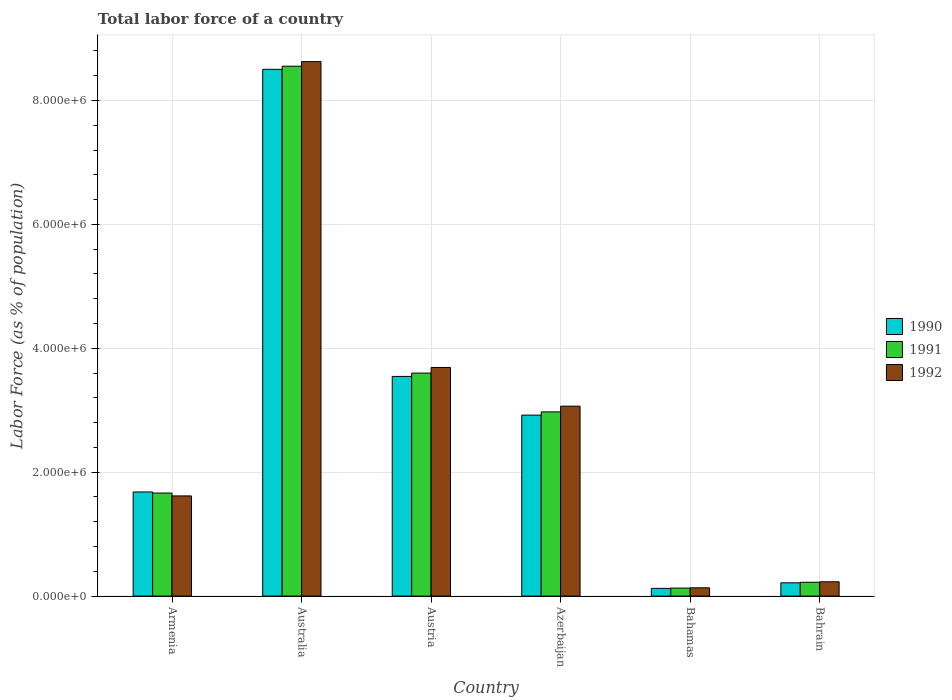How many different coloured bars are there?
Keep it short and to the point. 3. Are the number of bars per tick equal to the number of legend labels?
Your response must be concise. Yes. How many bars are there on the 1st tick from the left?
Your answer should be very brief. 3. How many bars are there on the 3rd tick from the right?
Your response must be concise. 3. What is the label of the 3rd group of bars from the left?
Offer a very short reply. Austria. In how many cases, is the number of bars for a given country not equal to the number of legend labels?
Provide a succinct answer. 0. What is the percentage of labor force in 1992 in Armenia?
Give a very brief answer. 1.62e+06. Across all countries, what is the maximum percentage of labor force in 1992?
Offer a very short reply. 8.63e+06. Across all countries, what is the minimum percentage of labor force in 1991?
Make the answer very short. 1.30e+05. In which country was the percentage of labor force in 1991 minimum?
Ensure brevity in your answer.  Bahamas. What is the total percentage of labor force in 1991 in the graph?
Give a very brief answer. 1.71e+07. What is the difference between the percentage of labor force in 1991 in Armenia and that in Australia?
Your answer should be very brief. -6.89e+06. What is the difference between the percentage of labor force in 1990 in Azerbaijan and the percentage of labor force in 1991 in Bahamas?
Offer a very short reply. 2.79e+06. What is the average percentage of labor force in 1990 per country?
Ensure brevity in your answer.  2.83e+06. What is the difference between the percentage of labor force of/in 1990 and percentage of labor force of/in 1991 in Australia?
Your response must be concise. -5.07e+04. In how many countries, is the percentage of labor force in 1991 greater than 2800000 %?
Offer a very short reply. 3. What is the ratio of the percentage of labor force in 1991 in Australia to that in Austria?
Ensure brevity in your answer.  2.38. Is the percentage of labor force in 1991 in Australia less than that in Austria?
Your answer should be very brief. No. Is the difference between the percentage of labor force in 1990 in Austria and Bahrain greater than the difference between the percentage of labor force in 1991 in Austria and Bahrain?
Keep it short and to the point. No. What is the difference between the highest and the second highest percentage of labor force in 1990?
Your answer should be very brief. 4.96e+06. What is the difference between the highest and the lowest percentage of labor force in 1991?
Your answer should be very brief. 8.42e+06. Is the sum of the percentage of labor force in 1990 in Australia and Azerbaijan greater than the maximum percentage of labor force in 1992 across all countries?
Provide a succinct answer. Yes. Is it the case that in every country, the sum of the percentage of labor force in 1992 and percentage of labor force in 1991 is greater than the percentage of labor force in 1990?
Offer a terse response. Yes. Are all the bars in the graph horizontal?
Offer a very short reply. No. How many countries are there in the graph?
Make the answer very short. 6. What is the difference between two consecutive major ticks on the Y-axis?
Your answer should be very brief. 2.00e+06. Are the values on the major ticks of Y-axis written in scientific E-notation?
Make the answer very short. Yes. Where does the legend appear in the graph?
Provide a short and direct response. Center right. How many legend labels are there?
Your response must be concise. 3. What is the title of the graph?
Your answer should be very brief. Total labor force of a country. Does "1978" appear as one of the legend labels in the graph?
Ensure brevity in your answer.  No. What is the label or title of the X-axis?
Make the answer very short. Country. What is the label or title of the Y-axis?
Provide a short and direct response. Labor Force (as % of population). What is the Labor Force (as % of population) of 1990 in Armenia?
Keep it short and to the point. 1.68e+06. What is the Labor Force (as % of population) of 1991 in Armenia?
Ensure brevity in your answer.  1.66e+06. What is the Labor Force (as % of population) of 1992 in Armenia?
Keep it short and to the point. 1.62e+06. What is the Labor Force (as % of population) in 1990 in Australia?
Your answer should be very brief. 8.50e+06. What is the Labor Force (as % of population) in 1991 in Australia?
Keep it short and to the point. 8.55e+06. What is the Labor Force (as % of population) in 1992 in Australia?
Your response must be concise. 8.63e+06. What is the Labor Force (as % of population) in 1990 in Austria?
Offer a terse response. 3.55e+06. What is the Labor Force (as % of population) of 1991 in Austria?
Offer a very short reply. 3.60e+06. What is the Labor Force (as % of population) in 1992 in Austria?
Provide a short and direct response. 3.69e+06. What is the Labor Force (as % of population) in 1990 in Azerbaijan?
Make the answer very short. 2.92e+06. What is the Labor Force (as % of population) of 1991 in Azerbaijan?
Your answer should be very brief. 2.97e+06. What is the Labor Force (as % of population) of 1992 in Azerbaijan?
Make the answer very short. 3.07e+06. What is the Labor Force (as % of population) in 1990 in Bahamas?
Keep it short and to the point. 1.25e+05. What is the Labor Force (as % of population) in 1991 in Bahamas?
Your answer should be compact. 1.30e+05. What is the Labor Force (as % of population) in 1992 in Bahamas?
Your response must be concise. 1.34e+05. What is the Labor Force (as % of population) of 1990 in Bahrain?
Your answer should be compact. 2.15e+05. What is the Labor Force (as % of population) in 1991 in Bahrain?
Provide a short and direct response. 2.23e+05. What is the Labor Force (as % of population) of 1992 in Bahrain?
Your answer should be very brief. 2.31e+05. Across all countries, what is the maximum Labor Force (as % of population) of 1990?
Give a very brief answer. 8.50e+06. Across all countries, what is the maximum Labor Force (as % of population) in 1991?
Your answer should be very brief. 8.55e+06. Across all countries, what is the maximum Labor Force (as % of population) in 1992?
Your response must be concise. 8.63e+06. Across all countries, what is the minimum Labor Force (as % of population) in 1990?
Offer a very short reply. 1.25e+05. Across all countries, what is the minimum Labor Force (as % of population) in 1991?
Your answer should be very brief. 1.30e+05. Across all countries, what is the minimum Labor Force (as % of population) of 1992?
Make the answer very short. 1.34e+05. What is the total Labor Force (as % of population) of 1990 in the graph?
Offer a terse response. 1.70e+07. What is the total Labor Force (as % of population) of 1991 in the graph?
Your response must be concise. 1.71e+07. What is the total Labor Force (as % of population) of 1992 in the graph?
Make the answer very short. 1.74e+07. What is the difference between the Labor Force (as % of population) of 1990 in Armenia and that in Australia?
Keep it short and to the point. -6.82e+06. What is the difference between the Labor Force (as % of population) in 1991 in Armenia and that in Australia?
Ensure brevity in your answer.  -6.89e+06. What is the difference between the Labor Force (as % of population) in 1992 in Armenia and that in Australia?
Your answer should be very brief. -7.01e+06. What is the difference between the Labor Force (as % of population) in 1990 in Armenia and that in Austria?
Your answer should be very brief. -1.86e+06. What is the difference between the Labor Force (as % of population) of 1991 in Armenia and that in Austria?
Your answer should be very brief. -1.94e+06. What is the difference between the Labor Force (as % of population) in 1992 in Armenia and that in Austria?
Make the answer very short. -2.07e+06. What is the difference between the Labor Force (as % of population) of 1990 in Armenia and that in Azerbaijan?
Offer a very short reply. -1.24e+06. What is the difference between the Labor Force (as % of population) of 1991 in Armenia and that in Azerbaijan?
Make the answer very short. -1.31e+06. What is the difference between the Labor Force (as % of population) of 1992 in Armenia and that in Azerbaijan?
Your answer should be very brief. -1.45e+06. What is the difference between the Labor Force (as % of population) in 1990 in Armenia and that in Bahamas?
Offer a very short reply. 1.56e+06. What is the difference between the Labor Force (as % of population) of 1991 in Armenia and that in Bahamas?
Make the answer very short. 1.53e+06. What is the difference between the Labor Force (as % of population) in 1992 in Armenia and that in Bahamas?
Your response must be concise. 1.48e+06. What is the difference between the Labor Force (as % of population) of 1990 in Armenia and that in Bahrain?
Offer a terse response. 1.47e+06. What is the difference between the Labor Force (as % of population) of 1991 in Armenia and that in Bahrain?
Ensure brevity in your answer.  1.44e+06. What is the difference between the Labor Force (as % of population) in 1992 in Armenia and that in Bahrain?
Your answer should be very brief. 1.39e+06. What is the difference between the Labor Force (as % of population) of 1990 in Australia and that in Austria?
Provide a short and direct response. 4.96e+06. What is the difference between the Labor Force (as % of population) of 1991 in Australia and that in Austria?
Your answer should be compact. 4.95e+06. What is the difference between the Labor Force (as % of population) in 1992 in Australia and that in Austria?
Provide a short and direct response. 4.94e+06. What is the difference between the Labor Force (as % of population) of 1990 in Australia and that in Azerbaijan?
Ensure brevity in your answer.  5.58e+06. What is the difference between the Labor Force (as % of population) in 1991 in Australia and that in Azerbaijan?
Keep it short and to the point. 5.58e+06. What is the difference between the Labor Force (as % of population) of 1992 in Australia and that in Azerbaijan?
Offer a terse response. 5.56e+06. What is the difference between the Labor Force (as % of population) of 1990 in Australia and that in Bahamas?
Make the answer very short. 8.38e+06. What is the difference between the Labor Force (as % of population) in 1991 in Australia and that in Bahamas?
Ensure brevity in your answer.  8.42e+06. What is the difference between the Labor Force (as % of population) in 1992 in Australia and that in Bahamas?
Keep it short and to the point. 8.49e+06. What is the difference between the Labor Force (as % of population) of 1990 in Australia and that in Bahrain?
Offer a very short reply. 8.29e+06. What is the difference between the Labor Force (as % of population) of 1991 in Australia and that in Bahrain?
Make the answer very short. 8.33e+06. What is the difference between the Labor Force (as % of population) in 1992 in Australia and that in Bahrain?
Your answer should be compact. 8.40e+06. What is the difference between the Labor Force (as % of population) in 1990 in Austria and that in Azerbaijan?
Your answer should be very brief. 6.25e+05. What is the difference between the Labor Force (as % of population) of 1991 in Austria and that in Azerbaijan?
Your answer should be compact. 6.26e+05. What is the difference between the Labor Force (as % of population) of 1992 in Austria and that in Azerbaijan?
Provide a short and direct response. 6.25e+05. What is the difference between the Labor Force (as % of population) in 1990 in Austria and that in Bahamas?
Offer a very short reply. 3.42e+06. What is the difference between the Labor Force (as % of population) of 1991 in Austria and that in Bahamas?
Offer a very short reply. 3.47e+06. What is the difference between the Labor Force (as % of population) of 1992 in Austria and that in Bahamas?
Your response must be concise. 3.56e+06. What is the difference between the Labor Force (as % of population) in 1990 in Austria and that in Bahrain?
Your answer should be very brief. 3.33e+06. What is the difference between the Labor Force (as % of population) of 1991 in Austria and that in Bahrain?
Ensure brevity in your answer.  3.38e+06. What is the difference between the Labor Force (as % of population) of 1992 in Austria and that in Bahrain?
Offer a terse response. 3.46e+06. What is the difference between the Labor Force (as % of population) of 1990 in Azerbaijan and that in Bahamas?
Your response must be concise. 2.80e+06. What is the difference between the Labor Force (as % of population) of 1991 in Azerbaijan and that in Bahamas?
Give a very brief answer. 2.84e+06. What is the difference between the Labor Force (as % of population) in 1992 in Azerbaijan and that in Bahamas?
Make the answer very short. 2.93e+06. What is the difference between the Labor Force (as % of population) in 1990 in Azerbaijan and that in Bahrain?
Provide a succinct answer. 2.71e+06. What is the difference between the Labor Force (as % of population) of 1991 in Azerbaijan and that in Bahrain?
Ensure brevity in your answer.  2.75e+06. What is the difference between the Labor Force (as % of population) of 1992 in Azerbaijan and that in Bahrain?
Your answer should be very brief. 2.83e+06. What is the difference between the Labor Force (as % of population) in 1990 in Bahamas and that in Bahrain?
Give a very brief answer. -8.99e+04. What is the difference between the Labor Force (as % of population) of 1991 in Bahamas and that in Bahrain?
Give a very brief answer. -9.36e+04. What is the difference between the Labor Force (as % of population) of 1992 in Bahamas and that in Bahrain?
Offer a terse response. -9.73e+04. What is the difference between the Labor Force (as % of population) of 1990 in Armenia and the Labor Force (as % of population) of 1991 in Australia?
Ensure brevity in your answer.  -6.87e+06. What is the difference between the Labor Force (as % of population) of 1990 in Armenia and the Labor Force (as % of population) of 1992 in Australia?
Offer a terse response. -6.95e+06. What is the difference between the Labor Force (as % of population) of 1991 in Armenia and the Labor Force (as % of population) of 1992 in Australia?
Offer a very short reply. -6.96e+06. What is the difference between the Labor Force (as % of population) of 1990 in Armenia and the Labor Force (as % of population) of 1991 in Austria?
Keep it short and to the point. -1.92e+06. What is the difference between the Labor Force (as % of population) in 1990 in Armenia and the Labor Force (as % of population) in 1992 in Austria?
Your answer should be very brief. -2.01e+06. What is the difference between the Labor Force (as % of population) in 1991 in Armenia and the Labor Force (as % of population) in 1992 in Austria?
Provide a short and direct response. -2.03e+06. What is the difference between the Labor Force (as % of population) in 1990 in Armenia and the Labor Force (as % of population) in 1991 in Azerbaijan?
Your answer should be compact. -1.29e+06. What is the difference between the Labor Force (as % of population) in 1990 in Armenia and the Labor Force (as % of population) in 1992 in Azerbaijan?
Ensure brevity in your answer.  -1.38e+06. What is the difference between the Labor Force (as % of population) in 1991 in Armenia and the Labor Force (as % of population) in 1992 in Azerbaijan?
Offer a terse response. -1.40e+06. What is the difference between the Labor Force (as % of population) in 1990 in Armenia and the Labor Force (as % of population) in 1991 in Bahamas?
Make the answer very short. 1.55e+06. What is the difference between the Labor Force (as % of population) in 1990 in Armenia and the Labor Force (as % of population) in 1992 in Bahamas?
Give a very brief answer. 1.55e+06. What is the difference between the Labor Force (as % of population) of 1991 in Armenia and the Labor Force (as % of population) of 1992 in Bahamas?
Ensure brevity in your answer.  1.53e+06. What is the difference between the Labor Force (as % of population) of 1990 in Armenia and the Labor Force (as % of population) of 1991 in Bahrain?
Your answer should be compact. 1.46e+06. What is the difference between the Labor Force (as % of population) in 1990 in Armenia and the Labor Force (as % of population) in 1992 in Bahrain?
Offer a terse response. 1.45e+06. What is the difference between the Labor Force (as % of population) of 1991 in Armenia and the Labor Force (as % of population) of 1992 in Bahrain?
Make the answer very short. 1.43e+06. What is the difference between the Labor Force (as % of population) of 1990 in Australia and the Labor Force (as % of population) of 1991 in Austria?
Provide a succinct answer. 4.90e+06. What is the difference between the Labor Force (as % of population) in 1990 in Australia and the Labor Force (as % of population) in 1992 in Austria?
Keep it short and to the point. 4.81e+06. What is the difference between the Labor Force (as % of population) of 1991 in Australia and the Labor Force (as % of population) of 1992 in Austria?
Provide a short and direct response. 4.86e+06. What is the difference between the Labor Force (as % of population) of 1990 in Australia and the Labor Force (as % of population) of 1991 in Azerbaijan?
Your answer should be compact. 5.53e+06. What is the difference between the Labor Force (as % of population) of 1990 in Australia and the Labor Force (as % of population) of 1992 in Azerbaijan?
Ensure brevity in your answer.  5.44e+06. What is the difference between the Labor Force (as % of population) in 1991 in Australia and the Labor Force (as % of population) in 1992 in Azerbaijan?
Make the answer very short. 5.49e+06. What is the difference between the Labor Force (as % of population) in 1990 in Australia and the Labor Force (as % of population) in 1991 in Bahamas?
Provide a succinct answer. 8.37e+06. What is the difference between the Labor Force (as % of population) of 1990 in Australia and the Labor Force (as % of population) of 1992 in Bahamas?
Provide a succinct answer. 8.37e+06. What is the difference between the Labor Force (as % of population) of 1991 in Australia and the Labor Force (as % of population) of 1992 in Bahamas?
Keep it short and to the point. 8.42e+06. What is the difference between the Labor Force (as % of population) of 1990 in Australia and the Labor Force (as % of population) of 1991 in Bahrain?
Your answer should be compact. 8.28e+06. What is the difference between the Labor Force (as % of population) of 1990 in Australia and the Labor Force (as % of population) of 1992 in Bahrain?
Offer a very short reply. 8.27e+06. What is the difference between the Labor Force (as % of population) in 1991 in Australia and the Labor Force (as % of population) in 1992 in Bahrain?
Ensure brevity in your answer.  8.32e+06. What is the difference between the Labor Force (as % of population) of 1990 in Austria and the Labor Force (as % of population) of 1991 in Azerbaijan?
Your answer should be very brief. 5.72e+05. What is the difference between the Labor Force (as % of population) of 1990 in Austria and the Labor Force (as % of population) of 1992 in Azerbaijan?
Keep it short and to the point. 4.80e+05. What is the difference between the Labor Force (as % of population) in 1991 in Austria and the Labor Force (as % of population) in 1992 in Azerbaijan?
Offer a very short reply. 5.34e+05. What is the difference between the Labor Force (as % of population) of 1990 in Austria and the Labor Force (as % of population) of 1991 in Bahamas?
Ensure brevity in your answer.  3.42e+06. What is the difference between the Labor Force (as % of population) in 1990 in Austria and the Labor Force (as % of population) in 1992 in Bahamas?
Provide a succinct answer. 3.41e+06. What is the difference between the Labor Force (as % of population) of 1991 in Austria and the Labor Force (as % of population) of 1992 in Bahamas?
Provide a succinct answer. 3.47e+06. What is the difference between the Labor Force (as % of population) in 1990 in Austria and the Labor Force (as % of population) in 1991 in Bahrain?
Provide a short and direct response. 3.32e+06. What is the difference between the Labor Force (as % of population) of 1990 in Austria and the Labor Force (as % of population) of 1992 in Bahrain?
Your answer should be very brief. 3.31e+06. What is the difference between the Labor Force (as % of population) in 1991 in Austria and the Labor Force (as % of population) in 1992 in Bahrain?
Keep it short and to the point. 3.37e+06. What is the difference between the Labor Force (as % of population) in 1990 in Azerbaijan and the Labor Force (as % of population) in 1991 in Bahamas?
Provide a short and direct response. 2.79e+06. What is the difference between the Labor Force (as % of population) of 1990 in Azerbaijan and the Labor Force (as % of population) of 1992 in Bahamas?
Offer a very short reply. 2.79e+06. What is the difference between the Labor Force (as % of population) of 1991 in Azerbaijan and the Labor Force (as % of population) of 1992 in Bahamas?
Provide a short and direct response. 2.84e+06. What is the difference between the Labor Force (as % of population) in 1990 in Azerbaijan and the Labor Force (as % of population) in 1991 in Bahrain?
Provide a short and direct response. 2.70e+06. What is the difference between the Labor Force (as % of population) of 1990 in Azerbaijan and the Labor Force (as % of population) of 1992 in Bahrain?
Your response must be concise. 2.69e+06. What is the difference between the Labor Force (as % of population) in 1991 in Azerbaijan and the Labor Force (as % of population) in 1992 in Bahrain?
Your answer should be compact. 2.74e+06. What is the difference between the Labor Force (as % of population) in 1990 in Bahamas and the Labor Force (as % of population) in 1991 in Bahrain?
Your response must be concise. -9.84e+04. What is the difference between the Labor Force (as % of population) of 1990 in Bahamas and the Labor Force (as % of population) of 1992 in Bahrain?
Keep it short and to the point. -1.06e+05. What is the difference between the Labor Force (as % of population) in 1991 in Bahamas and the Labor Force (as % of population) in 1992 in Bahrain?
Provide a succinct answer. -1.02e+05. What is the average Labor Force (as % of population) in 1990 per country?
Offer a terse response. 2.83e+06. What is the average Labor Force (as % of population) of 1991 per country?
Your response must be concise. 2.86e+06. What is the average Labor Force (as % of population) in 1992 per country?
Your answer should be very brief. 2.89e+06. What is the difference between the Labor Force (as % of population) in 1990 and Labor Force (as % of population) in 1991 in Armenia?
Your answer should be compact. 1.74e+04. What is the difference between the Labor Force (as % of population) of 1990 and Labor Force (as % of population) of 1992 in Armenia?
Offer a terse response. 6.37e+04. What is the difference between the Labor Force (as % of population) of 1991 and Labor Force (as % of population) of 1992 in Armenia?
Give a very brief answer. 4.64e+04. What is the difference between the Labor Force (as % of population) in 1990 and Labor Force (as % of population) in 1991 in Australia?
Offer a very short reply. -5.07e+04. What is the difference between the Labor Force (as % of population) in 1990 and Labor Force (as % of population) in 1992 in Australia?
Provide a short and direct response. -1.25e+05. What is the difference between the Labor Force (as % of population) in 1991 and Labor Force (as % of population) in 1992 in Australia?
Give a very brief answer. -7.41e+04. What is the difference between the Labor Force (as % of population) in 1990 and Labor Force (as % of population) in 1991 in Austria?
Provide a succinct answer. -5.39e+04. What is the difference between the Labor Force (as % of population) of 1990 and Labor Force (as % of population) of 1992 in Austria?
Offer a very short reply. -1.45e+05. What is the difference between the Labor Force (as % of population) in 1991 and Labor Force (as % of population) in 1992 in Austria?
Offer a very short reply. -9.07e+04. What is the difference between the Labor Force (as % of population) in 1990 and Labor Force (as % of population) in 1991 in Azerbaijan?
Provide a succinct answer. -5.22e+04. What is the difference between the Labor Force (as % of population) in 1990 and Labor Force (as % of population) in 1992 in Azerbaijan?
Keep it short and to the point. -1.45e+05. What is the difference between the Labor Force (as % of population) of 1991 and Labor Force (as % of population) of 1992 in Azerbaijan?
Ensure brevity in your answer.  -9.24e+04. What is the difference between the Labor Force (as % of population) of 1990 and Labor Force (as % of population) of 1991 in Bahamas?
Make the answer very short. -4809. What is the difference between the Labor Force (as % of population) in 1990 and Labor Force (as % of population) in 1992 in Bahamas?
Provide a short and direct response. -9039. What is the difference between the Labor Force (as % of population) in 1991 and Labor Force (as % of population) in 1992 in Bahamas?
Give a very brief answer. -4230. What is the difference between the Labor Force (as % of population) of 1990 and Labor Force (as % of population) of 1991 in Bahrain?
Make the answer very short. -8495. What is the difference between the Labor Force (as % of population) of 1990 and Labor Force (as % of population) of 1992 in Bahrain?
Your answer should be compact. -1.64e+04. What is the difference between the Labor Force (as % of population) in 1991 and Labor Force (as % of population) in 1992 in Bahrain?
Your response must be concise. -7946. What is the ratio of the Labor Force (as % of population) in 1990 in Armenia to that in Australia?
Provide a short and direct response. 0.2. What is the ratio of the Labor Force (as % of population) of 1991 in Armenia to that in Australia?
Give a very brief answer. 0.19. What is the ratio of the Labor Force (as % of population) in 1992 in Armenia to that in Australia?
Offer a terse response. 0.19. What is the ratio of the Labor Force (as % of population) in 1990 in Armenia to that in Austria?
Offer a very short reply. 0.47. What is the ratio of the Labor Force (as % of population) in 1991 in Armenia to that in Austria?
Keep it short and to the point. 0.46. What is the ratio of the Labor Force (as % of population) of 1992 in Armenia to that in Austria?
Provide a short and direct response. 0.44. What is the ratio of the Labor Force (as % of population) in 1990 in Armenia to that in Azerbaijan?
Offer a terse response. 0.58. What is the ratio of the Labor Force (as % of population) in 1991 in Armenia to that in Azerbaijan?
Your response must be concise. 0.56. What is the ratio of the Labor Force (as % of population) in 1992 in Armenia to that in Azerbaijan?
Make the answer very short. 0.53. What is the ratio of the Labor Force (as % of population) of 1990 in Armenia to that in Bahamas?
Ensure brevity in your answer.  13.48. What is the ratio of the Labor Force (as % of population) in 1991 in Armenia to that in Bahamas?
Give a very brief answer. 12.84. What is the ratio of the Labor Force (as % of population) in 1992 in Armenia to that in Bahamas?
Provide a succinct answer. 12.09. What is the ratio of the Labor Force (as % of population) of 1990 in Armenia to that in Bahrain?
Your answer should be very brief. 7.83. What is the ratio of the Labor Force (as % of population) of 1991 in Armenia to that in Bahrain?
Your response must be concise. 7.46. What is the ratio of the Labor Force (as % of population) in 1992 in Armenia to that in Bahrain?
Ensure brevity in your answer.  7. What is the ratio of the Labor Force (as % of population) of 1990 in Australia to that in Austria?
Your answer should be compact. 2.4. What is the ratio of the Labor Force (as % of population) of 1991 in Australia to that in Austria?
Your answer should be compact. 2.38. What is the ratio of the Labor Force (as % of population) of 1992 in Australia to that in Austria?
Your response must be concise. 2.34. What is the ratio of the Labor Force (as % of population) in 1990 in Australia to that in Azerbaijan?
Your answer should be compact. 2.91. What is the ratio of the Labor Force (as % of population) of 1991 in Australia to that in Azerbaijan?
Offer a very short reply. 2.88. What is the ratio of the Labor Force (as % of population) of 1992 in Australia to that in Azerbaijan?
Offer a terse response. 2.81. What is the ratio of the Labor Force (as % of population) in 1990 in Australia to that in Bahamas?
Give a very brief answer. 68.18. What is the ratio of the Labor Force (as % of population) of 1991 in Australia to that in Bahamas?
Your answer should be compact. 66.04. What is the ratio of the Labor Force (as % of population) of 1992 in Australia to that in Bahamas?
Your answer should be very brief. 64.51. What is the ratio of the Labor Force (as % of population) of 1990 in Australia to that in Bahrain?
Offer a terse response. 39.62. What is the ratio of the Labor Force (as % of population) in 1991 in Australia to that in Bahrain?
Ensure brevity in your answer.  38.33. What is the ratio of the Labor Force (as % of population) of 1992 in Australia to that in Bahrain?
Make the answer very short. 37.34. What is the ratio of the Labor Force (as % of population) of 1990 in Austria to that in Azerbaijan?
Ensure brevity in your answer.  1.21. What is the ratio of the Labor Force (as % of population) of 1991 in Austria to that in Azerbaijan?
Provide a succinct answer. 1.21. What is the ratio of the Labor Force (as % of population) of 1992 in Austria to that in Azerbaijan?
Offer a very short reply. 1.2. What is the ratio of the Labor Force (as % of population) of 1990 in Austria to that in Bahamas?
Your answer should be compact. 28.43. What is the ratio of the Labor Force (as % of population) of 1991 in Austria to that in Bahamas?
Provide a short and direct response. 27.79. What is the ratio of the Labor Force (as % of population) in 1992 in Austria to that in Bahamas?
Provide a short and direct response. 27.59. What is the ratio of the Labor Force (as % of population) in 1990 in Austria to that in Bahrain?
Provide a short and direct response. 16.52. What is the ratio of the Labor Force (as % of population) of 1991 in Austria to that in Bahrain?
Offer a very short reply. 16.13. What is the ratio of the Labor Force (as % of population) of 1992 in Austria to that in Bahrain?
Offer a very short reply. 15.97. What is the ratio of the Labor Force (as % of population) of 1990 in Azerbaijan to that in Bahamas?
Provide a succinct answer. 23.42. What is the ratio of the Labor Force (as % of population) of 1991 in Azerbaijan to that in Bahamas?
Provide a short and direct response. 22.96. What is the ratio of the Labor Force (as % of population) in 1992 in Azerbaijan to that in Bahamas?
Your answer should be compact. 22.92. What is the ratio of the Labor Force (as % of population) of 1990 in Azerbaijan to that in Bahrain?
Ensure brevity in your answer.  13.61. What is the ratio of the Labor Force (as % of population) in 1991 in Azerbaijan to that in Bahrain?
Offer a very short reply. 13.33. What is the ratio of the Labor Force (as % of population) of 1992 in Azerbaijan to that in Bahrain?
Provide a succinct answer. 13.27. What is the ratio of the Labor Force (as % of population) of 1990 in Bahamas to that in Bahrain?
Your answer should be very brief. 0.58. What is the ratio of the Labor Force (as % of population) of 1991 in Bahamas to that in Bahrain?
Give a very brief answer. 0.58. What is the ratio of the Labor Force (as % of population) in 1992 in Bahamas to that in Bahrain?
Give a very brief answer. 0.58. What is the difference between the highest and the second highest Labor Force (as % of population) of 1990?
Your answer should be very brief. 4.96e+06. What is the difference between the highest and the second highest Labor Force (as % of population) in 1991?
Your answer should be very brief. 4.95e+06. What is the difference between the highest and the second highest Labor Force (as % of population) in 1992?
Offer a very short reply. 4.94e+06. What is the difference between the highest and the lowest Labor Force (as % of population) in 1990?
Offer a terse response. 8.38e+06. What is the difference between the highest and the lowest Labor Force (as % of population) in 1991?
Provide a short and direct response. 8.42e+06. What is the difference between the highest and the lowest Labor Force (as % of population) of 1992?
Ensure brevity in your answer.  8.49e+06. 